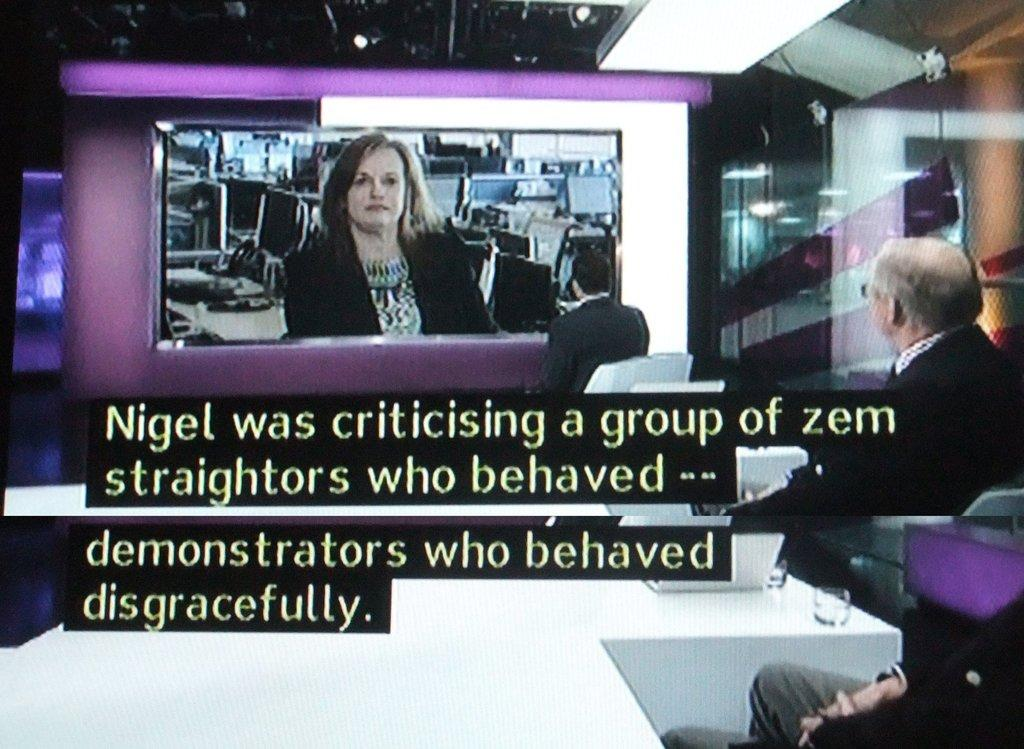Provide a one-sentence caption for the provided image. Men watch a television screen which depicts Nigel criticizing a group of Zem demonstrators who behaved disgracefully.t. 